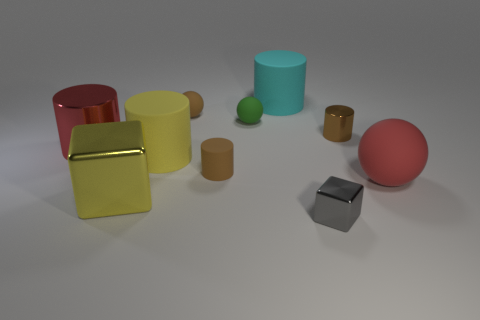Do the tiny gray object and the yellow metallic object have the same shape?
Your response must be concise. Yes. Is there anything else of the same color as the big block?
Ensure brevity in your answer.  Yes. What is the shape of the large yellow thing that is made of the same material as the green thing?
Provide a short and direct response. Cylinder. There is a large red thing that is on the right side of the brown sphere that is in front of the big cyan cylinder; what is it made of?
Make the answer very short. Rubber. There is a large matte object behind the small brown metal cylinder; is it the same shape as the large red metal object?
Give a very brief answer. Yes. Are there more big metallic objects that are on the left side of the large yellow shiny cube than small purple rubber things?
Provide a succinct answer. Yes. Is there anything else that has the same material as the yellow cylinder?
Make the answer very short. Yes. What is the shape of the big object that is the same color as the big shiny block?
Provide a short and direct response. Cylinder. How many balls are yellow rubber objects or large shiny things?
Your response must be concise. 0. There is a metallic cylinder to the left of the brown object to the right of the gray shiny cube; what color is it?
Keep it short and to the point. Red. 